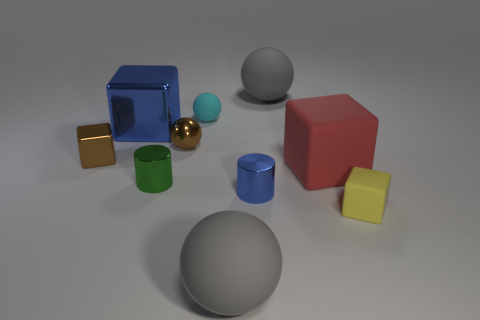Is there a rubber ball that has the same color as the small metallic sphere?
Give a very brief answer. No. What size is the blue cylinder that is the same material as the tiny green cylinder?
Offer a very short reply. Small. There is a metal thing that is the same color as the metallic ball; what is its size?
Ensure brevity in your answer.  Small. How many other things are the same size as the green thing?
Provide a succinct answer. 5. There is a tiny brown thing that is left of the tiny green metal cylinder; what is it made of?
Give a very brief answer. Metal. The gray rubber thing on the left side of the gray rubber thing on the right side of the big gray object that is in front of the yellow matte object is what shape?
Give a very brief answer. Sphere. Is the size of the yellow thing the same as the brown block?
Offer a very short reply. Yes. How many things are tiny blue matte things or small cubes right of the tiny cyan matte object?
Keep it short and to the point. 1. How many objects are either tiny matte things that are behind the small metal block or matte spheres that are left of the blue metallic cylinder?
Your answer should be compact. 2. Are there any green objects on the left side of the brown ball?
Keep it short and to the point. Yes. 